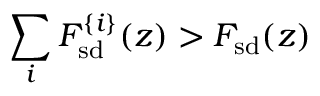Convert formula to latex. <formula><loc_0><loc_0><loc_500><loc_500>\sum _ { i } F _ { s d } ^ { \{ i \} } ( z ) > F _ { s d } ( z )</formula> 